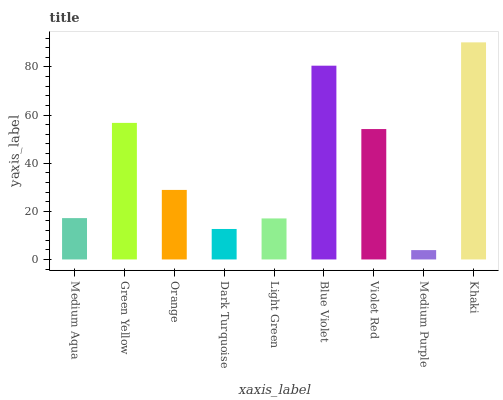Is Medium Purple the minimum?
Answer yes or no. Yes. Is Khaki the maximum?
Answer yes or no. Yes. Is Green Yellow the minimum?
Answer yes or no. No. Is Green Yellow the maximum?
Answer yes or no. No. Is Green Yellow greater than Medium Aqua?
Answer yes or no. Yes. Is Medium Aqua less than Green Yellow?
Answer yes or no. Yes. Is Medium Aqua greater than Green Yellow?
Answer yes or no. No. Is Green Yellow less than Medium Aqua?
Answer yes or no. No. Is Orange the high median?
Answer yes or no. Yes. Is Orange the low median?
Answer yes or no. Yes. Is Blue Violet the high median?
Answer yes or no. No. Is Medium Purple the low median?
Answer yes or no. No. 